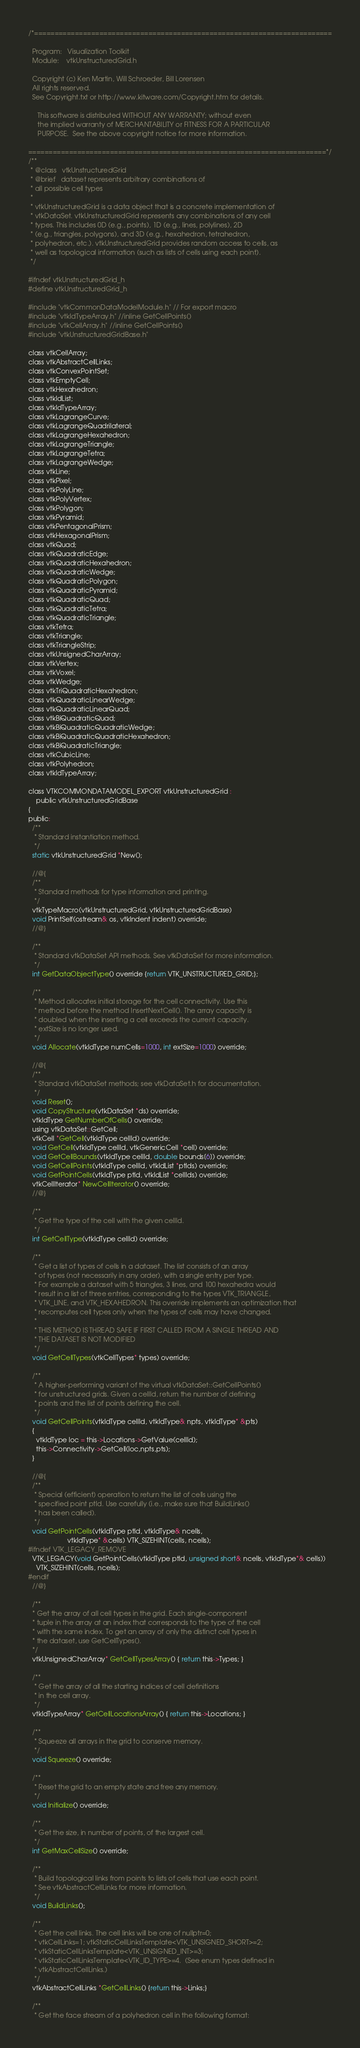<code> <loc_0><loc_0><loc_500><loc_500><_C_>/*=========================================================================

  Program:   Visualization Toolkit
  Module:    vtkUnstructuredGrid.h

  Copyright (c) Ken Martin, Will Schroeder, Bill Lorensen
  All rights reserved.
  See Copyright.txt or http://www.kitware.com/Copyright.htm for details.

     This software is distributed WITHOUT ANY WARRANTY; without even
     the implied warranty of MERCHANTABILITY or FITNESS FOR A PARTICULAR
     PURPOSE.  See the above copyright notice for more information.

=========================================================================*/
/**
 * @class   vtkUnstructuredGrid
 * @brief   dataset represents arbitrary combinations of
 * all possible cell types
 *
 * vtkUnstructuredGrid is a data object that is a concrete implementation of
 * vtkDataSet. vtkUnstructuredGrid represents any combinations of any cell
 * types. This includes 0D (e.g., points), 1D (e.g., lines, polylines), 2D
 * (e.g., triangles, polygons), and 3D (e.g., hexahedron, tetrahedron,
 * polyhedron, etc.). vtkUnstructuredGrid provides random access to cells, as
 * well as topological information (such as lists of cells using each point).
 */

#ifndef vtkUnstructuredGrid_h
#define vtkUnstructuredGrid_h

#include "vtkCommonDataModelModule.h" // For export macro
#include "vtkIdTypeArray.h" //inline GetCellPoints()
#include "vtkCellArray.h" //inline GetCellPoints()
#include "vtkUnstructuredGridBase.h"

class vtkCellArray;
class vtkAbstractCellLinks;
class vtkConvexPointSet;
class vtkEmptyCell;
class vtkHexahedron;
class vtkIdList;
class vtkIdTypeArray;
class vtkLagrangeCurve;
class vtkLagrangeQuadrilateral;
class vtkLagrangeHexahedron;
class vtkLagrangeTriangle;
class vtkLagrangeTetra;
class vtkLagrangeWedge;
class vtkLine;
class vtkPixel;
class vtkPolyLine;
class vtkPolyVertex;
class vtkPolygon;
class vtkPyramid;
class vtkPentagonalPrism;
class vtkHexagonalPrism;
class vtkQuad;
class vtkQuadraticEdge;
class vtkQuadraticHexahedron;
class vtkQuadraticWedge;
class vtkQuadraticPolygon;
class vtkQuadraticPyramid;
class vtkQuadraticQuad;
class vtkQuadraticTetra;
class vtkQuadraticTriangle;
class vtkTetra;
class vtkTriangle;
class vtkTriangleStrip;
class vtkUnsignedCharArray;
class vtkVertex;
class vtkVoxel;
class vtkWedge;
class vtkTriQuadraticHexahedron;
class vtkQuadraticLinearWedge;
class vtkQuadraticLinearQuad;
class vtkBiQuadraticQuad;
class vtkBiQuadraticQuadraticWedge;
class vtkBiQuadraticQuadraticHexahedron;
class vtkBiQuadraticTriangle;
class vtkCubicLine;
class vtkPolyhedron;
class vtkIdTypeArray;

class VTKCOMMONDATAMODEL_EXPORT vtkUnstructuredGrid :
    public vtkUnstructuredGridBase
{
public:
  /**
   * Standard instantiation method.
   */
  static vtkUnstructuredGrid *New();

  //@{
  /**
   * Standard methods for type information and printing.
   */
  vtkTypeMacro(vtkUnstructuredGrid, vtkUnstructuredGridBase)
  void PrintSelf(ostream& os, vtkIndent indent) override;
  //@}

  /**
   * Standard vtkDataSet API methods. See vtkDataSet for more information.
   */
  int GetDataObjectType() override {return VTK_UNSTRUCTURED_GRID;};

  /**
   * Method allocates initial storage for the cell connectivity. Use this
   * method before the method InsertNextCell(). The array capacity is
   * doubled when the inserting a cell exceeds the current capacity.
   * extSize is no longer used.
   */
  void Allocate(vtkIdType numCells=1000, int extSize=1000) override;

  //@{
  /**
   * Standard vtkDataSet methods; see vtkDataSet.h for documentation.
   */
  void Reset();
  void CopyStructure(vtkDataSet *ds) override;
  vtkIdType GetNumberOfCells() override;
  using vtkDataSet::GetCell;
  vtkCell *GetCell(vtkIdType cellId) override;
  void GetCell(vtkIdType cellId, vtkGenericCell *cell) override;
  void GetCellBounds(vtkIdType cellId, double bounds[6]) override;
  void GetCellPoints(vtkIdType cellId, vtkIdList *ptIds) override;
  void GetPointCells(vtkIdType ptId, vtkIdList *cellIds) override;
  vtkCellIterator* NewCellIterator() override;
  //@}

  /**
   * Get the type of the cell with the given cellId.
   */
  int GetCellType(vtkIdType cellId) override;

  /**
   * Get a list of types of cells in a dataset. The list consists of an array
   * of types (not necessarily in any order), with a single entry per type.
   * For example a dataset with 5 triangles, 3 lines, and 100 hexahedra would
   * result in a list of three entries, corresponding to the types VTK_TRIANGLE,
   * VTK_LINE, and VTK_HEXAHEDRON. This override implements an optimization that
   * recomputes cell types only when the types of cells may have changed.
   *
   * THIS METHOD IS THREAD SAFE IF FIRST CALLED FROM A SINGLE THREAD AND
   * THE DATASET IS NOT MODIFIED
   */
  void GetCellTypes(vtkCellTypes* types) override;

  /**
   * A higher-performing variant of the virtual vtkDataSet::GetCellPoints()
   * for unstructured grids. Given a cellId, return the number of defining
   * points and the list of points defining the cell.
   */
  void GetCellPoints(vtkIdType cellId, vtkIdType& npts, vtkIdType* &pts)
  {
    vtkIdType loc = this->Locations->GetValue(cellId);
    this->Connectivity->GetCell(loc,npts,pts);
  }

  //@{
  /**
   * Special (efficient) operation to return the list of cells using the
   * specified point ptId. Use carefully (i.e., make sure that BuildLinks()
   * has been called).
   */
  void GetPointCells(vtkIdType ptId, vtkIdType& ncells,
                     vtkIdType* &cells) VTK_SIZEHINT(cells, ncells);
#ifndef VTK_LEGACY_REMOVE
  VTK_LEGACY(void GetPointCells(vtkIdType ptId, unsigned short& ncells, vtkIdType*& cells))
    VTK_SIZEHINT(cells, ncells);
#endif
  //@}

  /**
  * Get the array of all cell types in the grid. Each single-component
  * tuple in the array at an index that corresponds to the type of the cell
  * with the same index. To get an array of only the distinct cell types in
  * the dataset, use GetCellTypes().
  */
  vtkUnsignedCharArray* GetCellTypesArray() { return this->Types; }

  /**
   * Get the array of all the starting indices of cell definitions
   * in the cell array.
   */
  vtkIdTypeArray* GetCellLocationsArray() { return this->Locations; }

  /**
   * Squeeze all arrays in the grid to conserve memory.
   */
  void Squeeze() override;

  /**
   * Reset the grid to an empty state and free any memory.
   */
  void Initialize() override;

  /**
   * Get the size, in number of points, of the largest cell.
   */
  int GetMaxCellSize() override;

  /**
   * Build topological links from points to lists of cells that use each point.
   * See vtkAbstractCellLinks for more information.
   */
  void BuildLinks();

  /**
   * Get the cell links. The cell links will be one of nullptr=0;
   * vtkCellLinks=1; vtkStaticCellLinksTemplate<VTK_UNSIGNED_SHORT>=2;
   * vtkStaticCellLinksTemplate<VTK_UNSIGNED_INT>=3;
   * vtkStaticCellLinksTemplate<VTK_ID_TYPE>=4.  (See enum types defined in
   * vtkAbstractCellLinks.)
   */
  vtkAbstractCellLinks *GetCellLinks() {return this->Links;}

  /**
   * Get the face stream of a polyhedron cell in the following format:</code> 